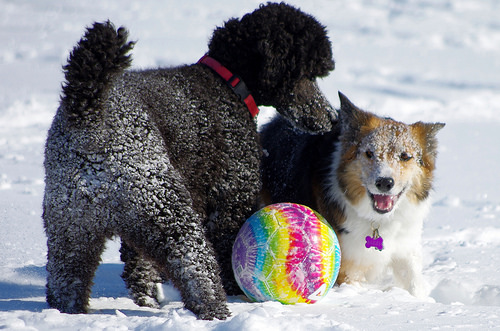<image>
Is there a ball on the snow? Yes. Looking at the image, I can see the ball is positioned on top of the snow, with the snow providing support. 